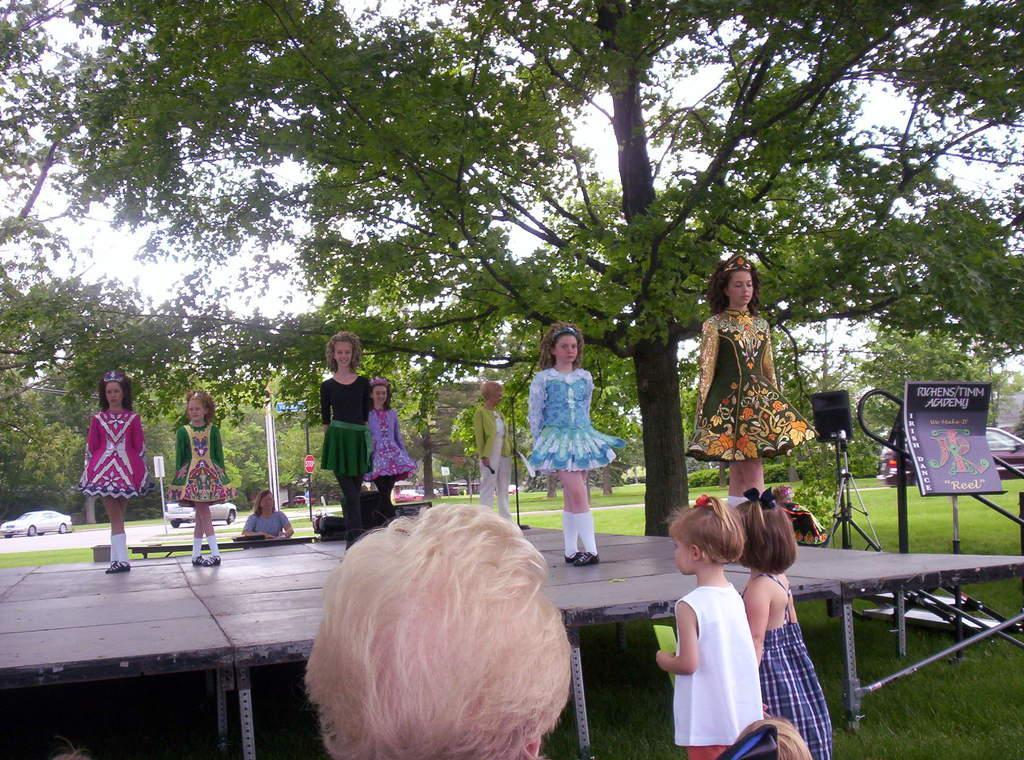Describe this image in one or two sentences. In this image I can see some people. On the right side, I can see a board with some text written on it. In the background, I can see the vehicles. I can also see the trees. 